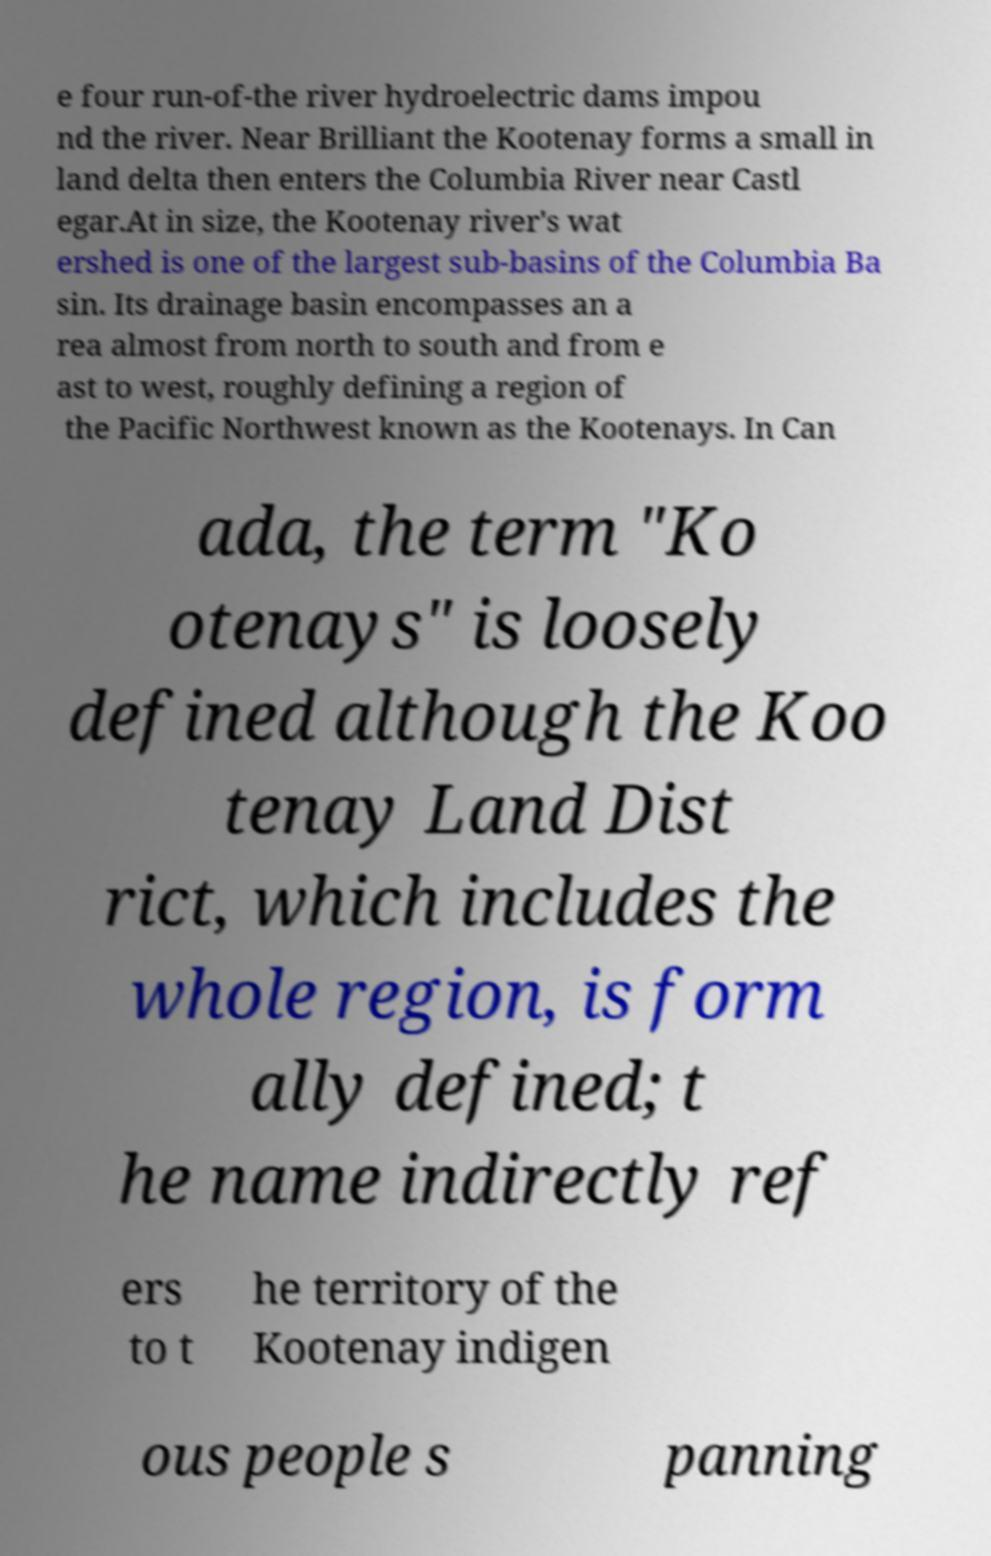Please identify and transcribe the text found in this image. e four run-of-the river hydroelectric dams impou nd the river. Near Brilliant the Kootenay forms a small in land delta then enters the Columbia River near Castl egar.At in size, the Kootenay river's wat ershed is one of the largest sub-basins of the Columbia Ba sin. Its drainage basin encompasses an a rea almost from north to south and from e ast to west, roughly defining a region of the Pacific Northwest known as the Kootenays. In Can ada, the term "Ko otenays" is loosely defined although the Koo tenay Land Dist rict, which includes the whole region, is form ally defined; t he name indirectly ref ers to t he territory of the Kootenay indigen ous people s panning 